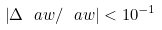<formula> <loc_0><loc_0><loc_500><loc_500>\left | \Delta \ a w / \ a w \right | < 1 0 ^ { - 1 }</formula> 